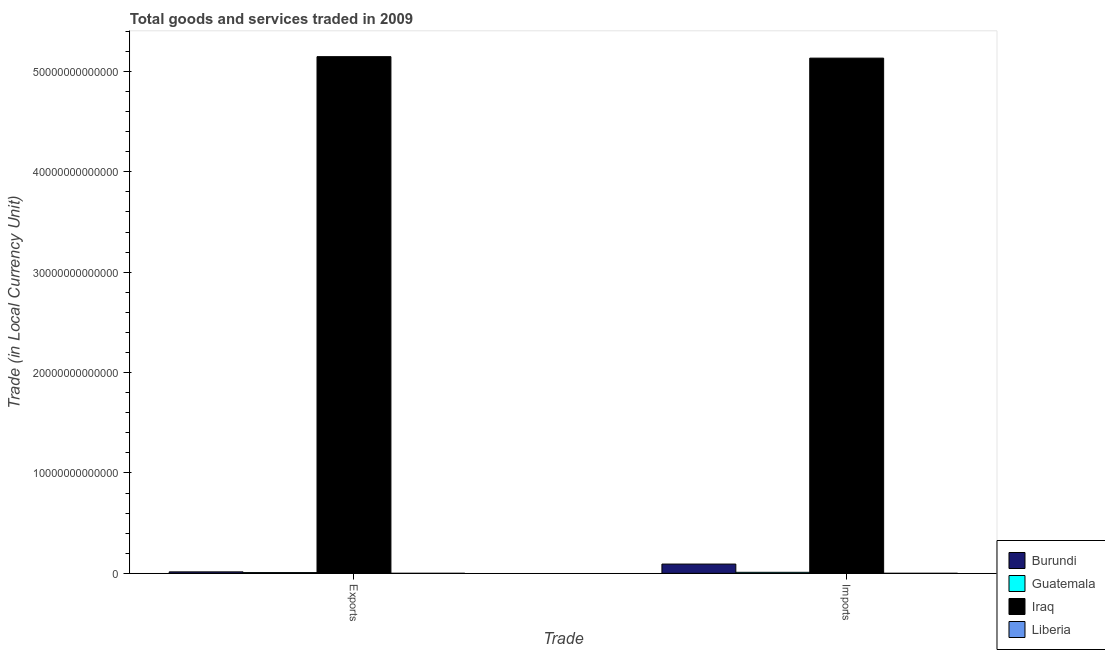How many different coloured bars are there?
Give a very brief answer. 4. How many groups of bars are there?
Offer a terse response. 2. Are the number of bars on each tick of the X-axis equal?
Offer a very short reply. Yes. How many bars are there on the 1st tick from the left?
Your answer should be very brief. 4. How many bars are there on the 2nd tick from the right?
Offer a terse response. 4. What is the label of the 1st group of bars from the left?
Make the answer very short. Exports. What is the export of goods and services in Guatemala?
Keep it short and to the point. 7.38e+1. Across all countries, what is the maximum export of goods and services?
Offer a terse response. 5.15e+13. Across all countries, what is the minimum export of goods and services?
Your answer should be compact. 4.91e+08. In which country was the export of goods and services maximum?
Ensure brevity in your answer.  Iraq. In which country was the imports of goods and services minimum?
Provide a short and direct response. Liberia. What is the total imports of goods and services in the graph?
Your answer should be compact. 5.24e+13. What is the difference between the imports of goods and services in Liberia and that in Burundi?
Give a very brief answer. -9.21e+11. What is the difference between the imports of goods and services in Guatemala and the export of goods and services in Iraq?
Your answer should be compact. -5.14e+13. What is the average export of goods and services per country?
Provide a short and direct response. 1.29e+13. What is the difference between the imports of goods and services and export of goods and services in Iraq?
Give a very brief answer. -1.47e+11. What is the ratio of the imports of goods and services in Iraq to that in Liberia?
Provide a succinct answer. 3.03e+04. Is the export of goods and services in Iraq less than that in Burundi?
Keep it short and to the point. No. In how many countries, is the imports of goods and services greater than the average imports of goods and services taken over all countries?
Offer a terse response. 1. What does the 1st bar from the left in Exports represents?
Keep it short and to the point. Burundi. What does the 4th bar from the right in Exports represents?
Ensure brevity in your answer.  Burundi. How many countries are there in the graph?
Offer a terse response. 4. What is the difference between two consecutive major ticks on the Y-axis?
Give a very brief answer. 1.00e+13. Does the graph contain any zero values?
Ensure brevity in your answer.  No. Does the graph contain grids?
Your response must be concise. No. Where does the legend appear in the graph?
Ensure brevity in your answer.  Bottom right. How are the legend labels stacked?
Provide a short and direct response. Vertical. What is the title of the graph?
Keep it short and to the point. Total goods and services traded in 2009. Does "Dominican Republic" appear as one of the legend labels in the graph?
Make the answer very short. No. What is the label or title of the X-axis?
Your response must be concise. Trade. What is the label or title of the Y-axis?
Your answer should be very brief. Trade (in Local Currency Unit). What is the Trade (in Local Currency Unit) of Burundi in Exports?
Your answer should be compact. 1.46e+11. What is the Trade (in Local Currency Unit) of Guatemala in Exports?
Your answer should be very brief. 7.38e+1. What is the Trade (in Local Currency Unit) in Iraq in Exports?
Your answer should be compact. 5.15e+13. What is the Trade (in Local Currency Unit) in Liberia in Exports?
Provide a succinct answer. 4.91e+08. What is the Trade (in Local Currency Unit) in Burundi in Imports?
Provide a succinct answer. 9.23e+11. What is the Trade (in Local Currency Unit) in Guatemala in Imports?
Make the answer very short. 1.02e+11. What is the Trade (in Local Currency Unit) in Iraq in Imports?
Provide a succinct answer. 5.13e+13. What is the Trade (in Local Currency Unit) of Liberia in Imports?
Provide a short and direct response. 1.69e+09. Across all Trade, what is the maximum Trade (in Local Currency Unit) of Burundi?
Your answer should be compact. 9.23e+11. Across all Trade, what is the maximum Trade (in Local Currency Unit) in Guatemala?
Ensure brevity in your answer.  1.02e+11. Across all Trade, what is the maximum Trade (in Local Currency Unit) in Iraq?
Ensure brevity in your answer.  5.15e+13. Across all Trade, what is the maximum Trade (in Local Currency Unit) in Liberia?
Provide a short and direct response. 1.69e+09. Across all Trade, what is the minimum Trade (in Local Currency Unit) of Burundi?
Ensure brevity in your answer.  1.46e+11. Across all Trade, what is the minimum Trade (in Local Currency Unit) of Guatemala?
Your response must be concise. 7.38e+1. Across all Trade, what is the minimum Trade (in Local Currency Unit) of Iraq?
Your response must be concise. 5.13e+13. Across all Trade, what is the minimum Trade (in Local Currency Unit) in Liberia?
Keep it short and to the point. 4.91e+08. What is the total Trade (in Local Currency Unit) in Burundi in the graph?
Offer a terse response. 1.07e+12. What is the total Trade (in Local Currency Unit) in Guatemala in the graph?
Your answer should be very brief. 1.76e+11. What is the total Trade (in Local Currency Unit) in Iraq in the graph?
Make the answer very short. 1.03e+14. What is the total Trade (in Local Currency Unit) in Liberia in the graph?
Ensure brevity in your answer.  2.18e+09. What is the difference between the Trade (in Local Currency Unit) of Burundi in Exports and that in Imports?
Your response must be concise. -7.77e+11. What is the difference between the Trade (in Local Currency Unit) of Guatemala in Exports and that in Imports?
Offer a terse response. -2.82e+1. What is the difference between the Trade (in Local Currency Unit) in Iraq in Exports and that in Imports?
Make the answer very short. 1.47e+11. What is the difference between the Trade (in Local Currency Unit) of Liberia in Exports and that in Imports?
Your response must be concise. -1.20e+09. What is the difference between the Trade (in Local Currency Unit) in Burundi in Exports and the Trade (in Local Currency Unit) in Guatemala in Imports?
Make the answer very short. 4.36e+1. What is the difference between the Trade (in Local Currency Unit) in Burundi in Exports and the Trade (in Local Currency Unit) in Iraq in Imports?
Provide a succinct answer. -5.12e+13. What is the difference between the Trade (in Local Currency Unit) of Burundi in Exports and the Trade (in Local Currency Unit) of Liberia in Imports?
Your response must be concise. 1.44e+11. What is the difference between the Trade (in Local Currency Unit) in Guatemala in Exports and the Trade (in Local Currency Unit) in Iraq in Imports?
Your response must be concise. -5.13e+13. What is the difference between the Trade (in Local Currency Unit) in Guatemala in Exports and the Trade (in Local Currency Unit) in Liberia in Imports?
Offer a very short reply. 7.21e+1. What is the difference between the Trade (in Local Currency Unit) in Iraq in Exports and the Trade (in Local Currency Unit) in Liberia in Imports?
Your answer should be very brief. 5.15e+13. What is the average Trade (in Local Currency Unit) of Burundi per Trade?
Your answer should be compact. 5.34e+11. What is the average Trade (in Local Currency Unit) in Guatemala per Trade?
Keep it short and to the point. 8.79e+1. What is the average Trade (in Local Currency Unit) of Iraq per Trade?
Provide a succinct answer. 5.14e+13. What is the average Trade (in Local Currency Unit) in Liberia per Trade?
Offer a terse response. 1.09e+09. What is the difference between the Trade (in Local Currency Unit) in Burundi and Trade (in Local Currency Unit) in Guatemala in Exports?
Your answer should be compact. 7.18e+1. What is the difference between the Trade (in Local Currency Unit) of Burundi and Trade (in Local Currency Unit) of Iraq in Exports?
Your answer should be very brief. -5.13e+13. What is the difference between the Trade (in Local Currency Unit) in Burundi and Trade (in Local Currency Unit) in Liberia in Exports?
Your answer should be very brief. 1.45e+11. What is the difference between the Trade (in Local Currency Unit) in Guatemala and Trade (in Local Currency Unit) in Iraq in Exports?
Offer a terse response. -5.14e+13. What is the difference between the Trade (in Local Currency Unit) in Guatemala and Trade (in Local Currency Unit) in Liberia in Exports?
Offer a terse response. 7.33e+1. What is the difference between the Trade (in Local Currency Unit) of Iraq and Trade (in Local Currency Unit) of Liberia in Exports?
Keep it short and to the point. 5.15e+13. What is the difference between the Trade (in Local Currency Unit) of Burundi and Trade (in Local Currency Unit) of Guatemala in Imports?
Your response must be concise. 8.21e+11. What is the difference between the Trade (in Local Currency Unit) in Burundi and Trade (in Local Currency Unit) in Iraq in Imports?
Offer a terse response. -5.04e+13. What is the difference between the Trade (in Local Currency Unit) of Burundi and Trade (in Local Currency Unit) of Liberia in Imports?
Provide a succinct answer. 9.21e+11. What is the difference between the Trade (in Local Currency Unit) in Guatemala and Trade (in Local Currency Unit) in Iraq in Imports?
Your answer should be compact. -5.12e+13. What is the difference between the Trade (in Local Currency Unit) in Guatemala and Trade (in Local Currency Unit) in Liberia in Imports?
Your response must be concise. 1.00e+11. What is the difference between the Trade (in Local Currency Unit) of Iraq and Trade (in Local Currency Unit) of Liberia in Imports?
Make the answer very short. 5.13e+13. What is the ratio of the Trade (in Local Currency Unit) of Burundi in Exports to that in Imports?
Offer a terse response. 0.16. What is the ratio of the Trade (in Local Currency Unit) in Guatemala in Exports to that in Imports?
Your answer should be compact. 0.72. What is the ratio of the Trade (in Local Currency Unit) in Liberia in Exports to that in Imports?
Your answer should be very brief. 0.29. What is the difference between the highest and the second highest Trade (in Local Currency Unit) in Burundi?
Your answer should be compact. 7.77e+11. What is the difference between the highest and the second highest Trade (in Local Currency Unit) in Guatemala?
Provide a short and direct response. 2.82e+1. What is the difference between the highest and the second highest Trade (in Local Currency Unit) in Iraq?
Provide a succinct answer. 1.47e+11. What is the difference between the highest and the second highest Trade (in Local Currency Unit) of Liberia?
Your response must be concise. 1.20e+09. What is the difference between the highest and the lowest Trade (in Local Currency Unit) in Burundi?
Provide a short and direct response. 7.77e+11. What is the difference between the highest and the lowest Trade (in Local Currency Unit) in Guatemala?
Keep it short and to the point. 2.82e+1. What is the difference between the highest and the lowest Trade (in Local Currency Unit) in Iraq?
Make the answer very short. 1.47e+11. What is the difference between the highest and the lowest Trade (in Local Currency Unit) in Liberia?
Your answer should be very brief. 1.20e+09. 